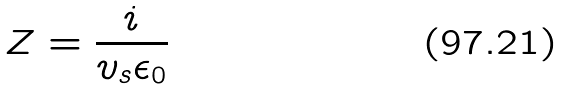<formula> <loc_0><loc_0><loc_500><loc_500>Z = \frac { i } { v _ { s } \epsilon _ { 0 } }</formula> 